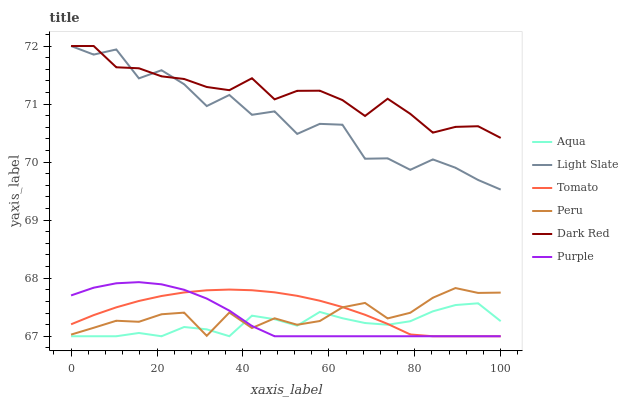Does Aqua have the minimum area under the curve?
Answer yes or no. Yes. Does Dark Red have the maximum area under the curve?
Answer yes or no. Yes. Does Light Slate have the minimum area under the curve?
Answer yes or no. No. Does Light Slate have the maximum area under the curve?
Answer yes or no. No. Is Tomato the smoothest?
Answer yes or no. Yes. Is Light Slate the roughest?
Answer yes or no. Yes. Is Dark Red the smoothest?
Answer yes or no. No. Is Dark Red the roughest?
Answer yes or no. No. Does Tomato have the lowest value?
Answer yes or no. Yes. Does Light Slate have the lowest value?
Answer yes or no. No. Does Dark Red have the highest value?
Answer yes or no. Yes. Does Aqua have the highest value?
Answer yes or no. No. Is Aqua less than Dark Red?
Answer yes or no. Yes. Is Light Slate greater than Tomato?
Answer yes or no. Yes. Does Light Slate intersect Dark Red?
Answer yes or no. Yes. Is Light Slate less than Dark Red?
Answer yes or no. No. Is Light Slate greater than Dark Red?
Answer yes or no. No. Does Aqua intersect Dark Red?
Answer yes or no. No. 